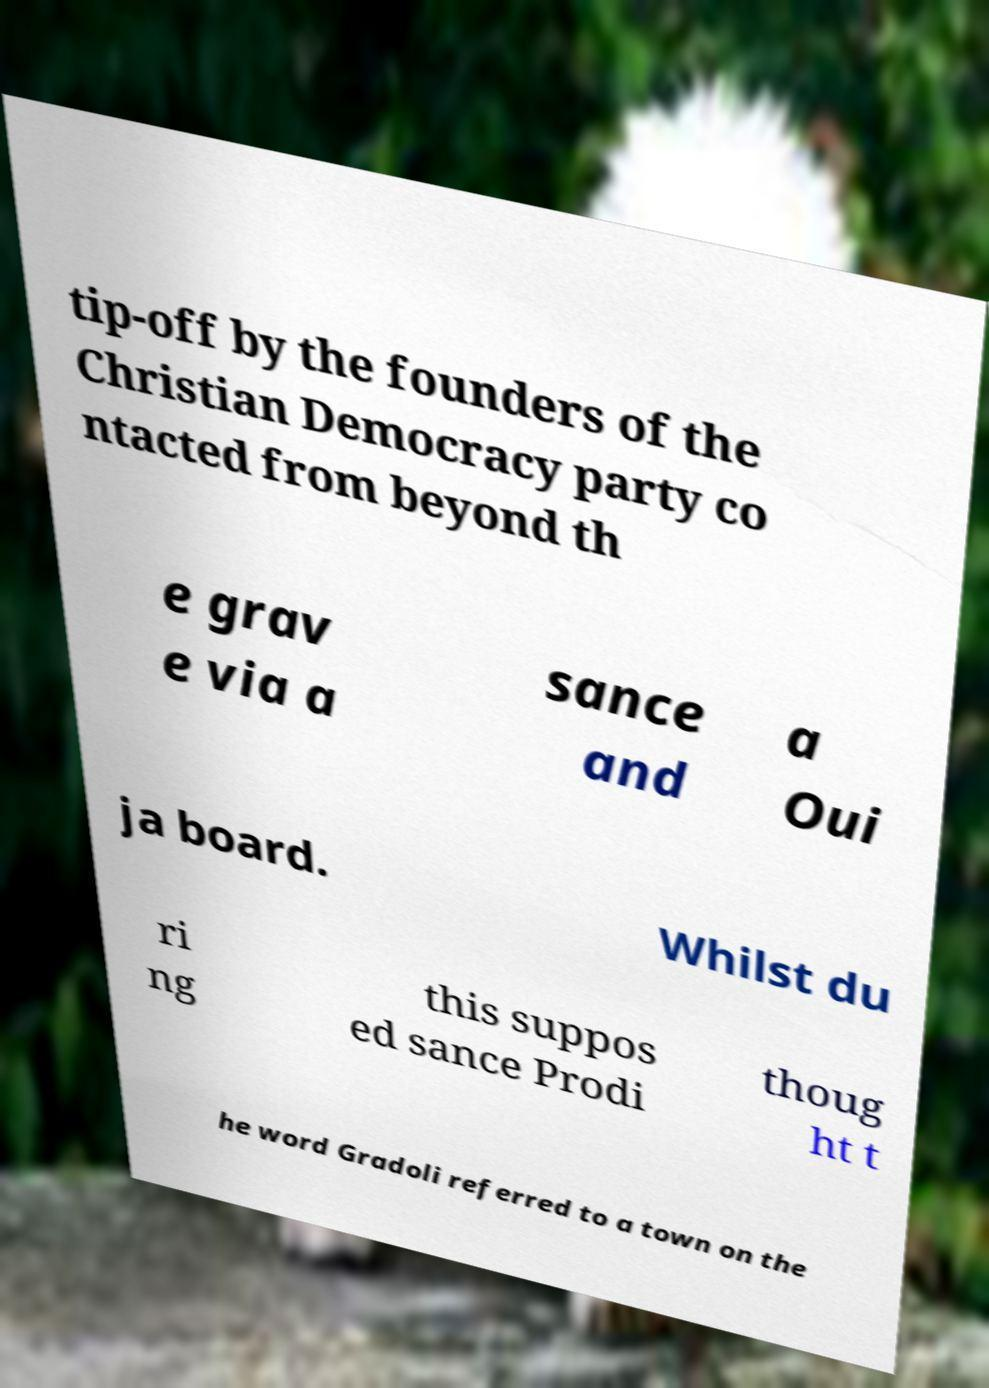There's text embedded in this image that I need extracted. Can you transcribe it verbatim? tip-off by the founders of the Christian Democracy party co ntacted from beyond th e grav e via a sance and a Oui ja board. Whilst du ri ng this suppos ed sance Prodi thoug ht t he word Gradoli referred to a town on the 